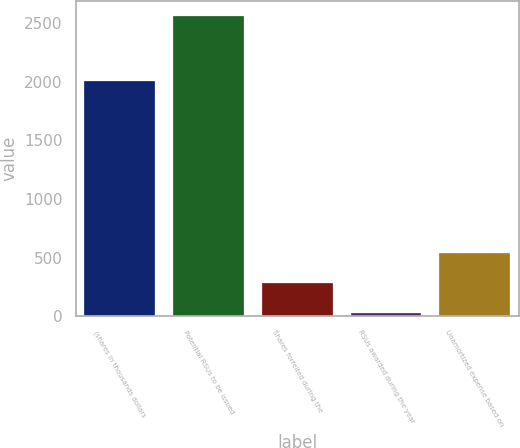Convert chart to OTSL. <chart><loc_0><loc_0><loc_500><loc_500><bar_chart><fcel>(shares in thousands dollars<fcel>Potential RSUs to be issued<fcel>Shares forfeited during the<fcel>RSUs awarded during the year<fcel>Unamortized expense based on<nl><fcel>2006<fcel>2560<fcel>283<fcel>30<fcel>536<nl></chart> 